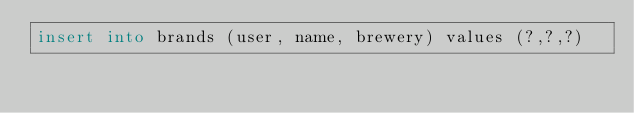Convert code to text. <code><loc_0><loc_0><loc_500><loc_500><_SQL_>insert into brands (user, name, brewery) values (?,?,?)</code> 